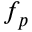<formula> <loc_0><loc_0><loc_500><loc_500>f _ { p }</formula> 